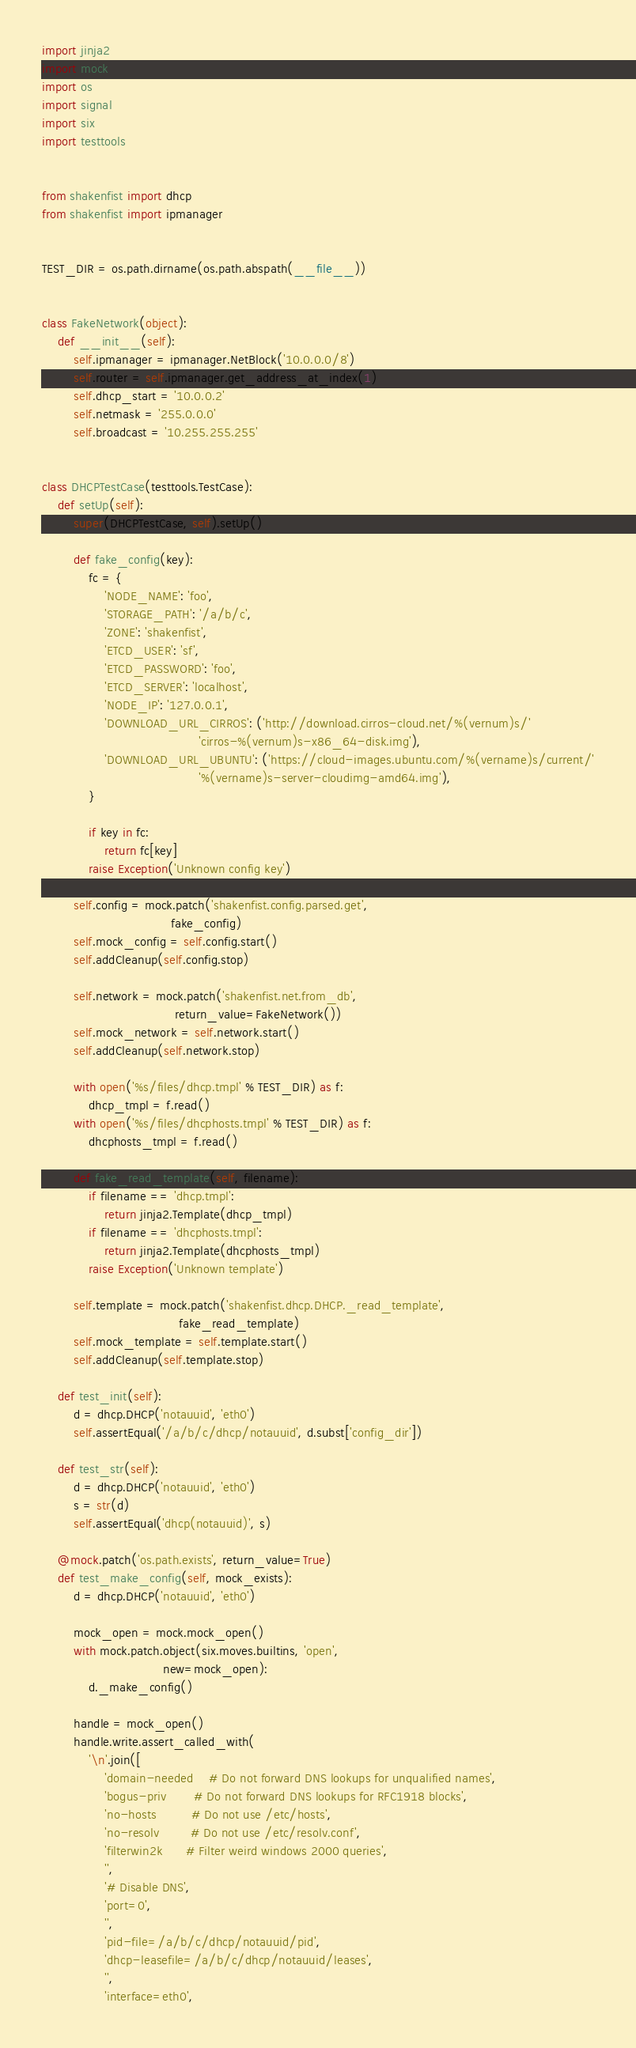Convert code to text. <code><loc_0><loc_0><loc_500><loc_500><_Python_>import jinja2
import mock
import os
import signal
import six
import testtools


from shakenfist import dhcp
from shakenfist import ipmanager


TEST_DIR = os.path.dirname(os.path.abspath(__file__))


class FakeNetwork(object):
    def __init__(self):
        self.ipmanager = ipmanager.NetBlock('10.0.0.0/8')
        self.router = self.ipmanager.get_address_at_index(1)
        self.dhcp_start = '10.0.0.2'
        self.netmask = '255.0.0.0'
        self.broadcast = '10.255.255.255'


class DHCPTestCase(testtools.TestCase):
    def setUp(self):
        super(DHCPTestCase, self).setUp()

        def fake_config(key):
            fc = {
                'NODE_NAME': 'foo',
                'STORAGE_PATH': '/a/b/c',
                'ZONE': 'shakenfist',
                'ETCD_USER': 'sf',
                'ETCD_PASSWORD': 'foo',
                'ETCD_SERVER': 'localhost',
                'NODE_IP': '127.0.0.1',
                'DOWNLOAD_URL_CIRROS': ('http://download.cirros-cloud.net/%(vernum)s/'
                                        'cirros-%(vernum)s-x86_64-disk.img'),
                'DOWNLOAD_URL_UBUNTU': ('https://cloud-images.ubuntu.com/%(vername)s/current/'
                                        '%(vername)s-server-cloudimg-amd64.img'),
            }

            if key in fc:
                return fc[key]
            raise Exception('Unknown config key')

        self.config = mock.patch('shakenfist.config.parsed.get',
                                 fake_config)
        self.mock_config = self.config.start()
        self.addCleanup(self.config.stop)

        self.network = mock.patch('shakenfist.net.from_db',
                                  return_value=FakeNetwork())
        self.mock_network = self.network.start()
        self.addCleanup(self.network.stop)

        with open('%s/files/dhcp.tmpl' % TEST_DIR) as f:
            dhcp_tmpl = f.read()
        with open('%s/files/dhcphosts.tmpl' % TEST_DIR) as f:
            dhcphosts_tmpl = f.read()

        def fake_read_template(self, filename):
            if filename == 'dhcp.tmpl':
                return jinja2.Template(dhcp_tmpl)
            if filename == 'dhcphosts.tmpl':
                return jinja2.Template(dhcphosts_tmpl)
            raise Exception('Unknown template')

        self.template = mock.patch('shakenfist.dhcp.DHCP._read_template',
                                   fake_read_template)
        self.mock_template = self.template.start()
        self.addCleanup(self.template.stop)

    def test_init(self):
        d = dhcp.DHCP('notauuid', 'eth0')
        self.assertEqual('/a/b/c/dhcp/notauuid', d.subst['config_dir'])

    def test_str(self):
        d = dhcp.DHCP('notauuid', 'eth0')
        s = str(d)
        self.assertEqual('dhcp(notauuid)', s)

    @mock.patch('os.path.exists', return_value=True)
    def test_make_config(self, mock_exists):
        d = dhcp.DHCP('notauuid', 'eth0')

        mock_open = mock.mock_open()
        with mock.patch.object(six.moves.builtins, 'open',
                               new=mock_open):
            d._make_config()

        handle = mock_open()
        handle.write.assert_called_with(
            '\n'.join([
                'domain-needed    # Do not forward DNS lookups for unqualified names',
                'bogus-priv       # Do not forward DNS lookups for RFC1918 blocks',
                'no-hosts         # Do not use /etc/hosts',
                'no-resolv        # Do not use /etc/resolv.conf',
                'filterwin2k      # Filter weird windows 2000 queries',
                '',
                '# Disable DNS',
                'port=0',
                '',
                'pid-file=/a/b/c/dhcp/notauuid/pid',
                'dhcp-leasefile=/a/b/c/dhcp/notauuid/leases',
                '',
                'interface=eth0',</code> 